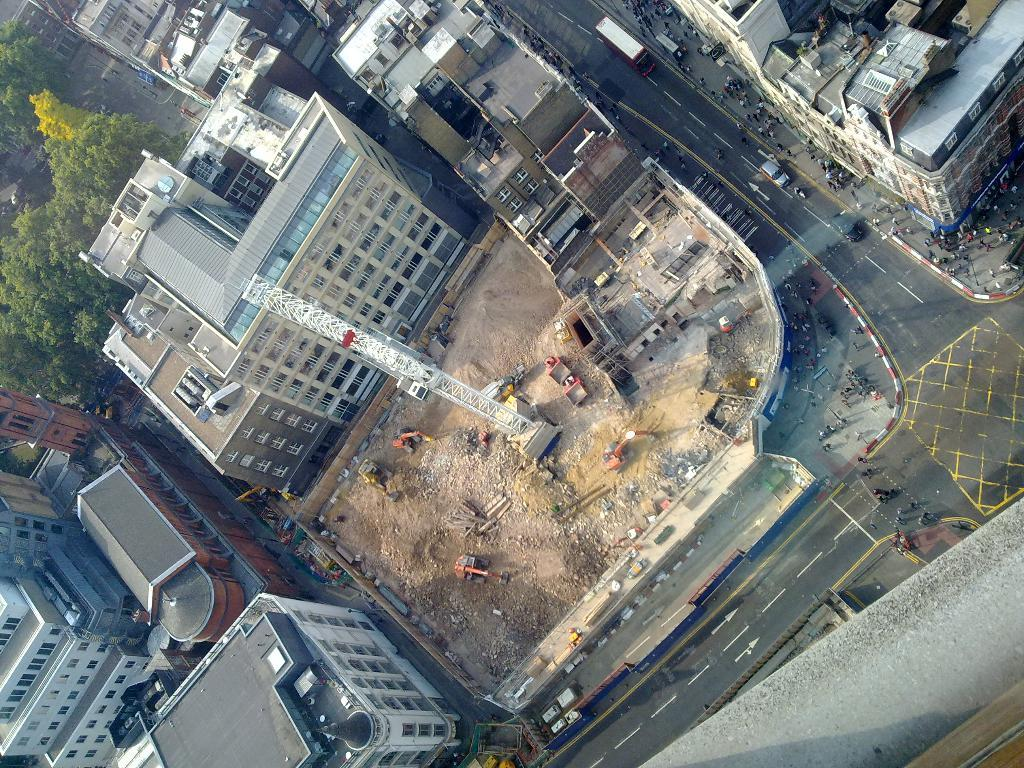What type of structures can be seen in the image? There are buildings in the image. What is the primary mode of transportation visible in the image? There are vehicles in the image. What is the purpose of the crane in the image? The crane in the image is likely being used for construction or lifting heavy objects. What type of vegetation is present in the image? There are trees in the image. What is the average income of the people living in the buildings in the image? There is no information about the income of the people living in the buildings in the image. Can you tell me how many cups are visible in the image? There are no cups present in the image. 